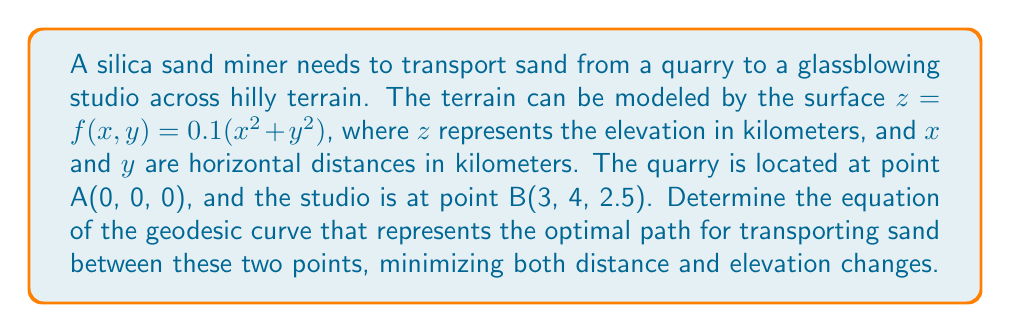Solve this math problem. To solve this problem, we'll use principles of differential geometry and the calculus of variations to find the geodesic curve on the given surface.

1. First, we need to parameterize the surface. Let's use the parameters $u$ and $v$:
   $x = u$, $y = v$, $z = 0.1(u^2 + v^2)$

2. The metric tensor for this surface is:
   $$g = \begin{bmatrix}
   1 + 0.04u^2 & 0.04uv \\
   0.04uv & 1 + 0.04v^2
   \end{bmatrix}$$

3. The geodesic equations are given by:
   $$\frac{d^2u}{ds^2} + \Gamma^u_{uu}\left(\frac{du}{ds}\right)^2 + 2\Gamma^u_{uv}\frac{du}{ds}\frac{dv}{ds} + \Gamma^u_{vv}\left(\frac{dv}{ds}\right)^2 = 0$$
   $$\frac{d^2v}{ds^2} + \Gamma^v_{uu}\left(\frac{du}{ds}\right)^2 + 2\Gamma^v_{uv}\frac{du}{ds}\frac{dv}{ds} + \Gamma^v_{vv}\left(\frac{dv}{ds}\right)^2 = 0$$

   where $\Gamma^i_{jk}$ are the Christoffel symbols.

4. Calculating the Christoffel symbols:
   $$\Gamma^u_{uu} = \frac{0.04u}{1 + 0.04u^2}, \Gamma^u_{uv} = \frac{-0.02v}{1 + 0.04u^2}, \Gamma^u_{vv} = \frac{0.04u}{1 + 0.04u^2}$$
   $$\Gamma^v_{uu} = \frac{0.04v}{1 + 0.04v^2}, \Gamma^v_{uv} = \frac{-0.02u}{1 + 0.04v^2}, \Gamma^v_{vv} = \frac{0.04v}{1 + 0.04v^2}$$

5. Substituting these into the geodesic equations gives us a system of differential equations. Due to the complexity of these equations, they typically need to be solved numerically.

6. The boundary conditions for our problem are:
   At $s = 0$: $u(0) = 0$, $v(0) = 0$
   At $s = 1$: $u(1) = 3$, $v(1) = 4$

7. Using a numerical method (such as the shooting method or finite differences) to solve this boundary value problem would give us the functions $u(s)$ and $v(s)$ that describe the geodesic curve.

8. The equation of the geodesic curve in the original $(x, y, z)$ coordinates would then be:
   $$x = u(s)$$
   $$y = v(s)$$
   $$z = 0.1(u(s)^2 + v(s)^2)$$
   for $0 \leq s \leq 1$
Answer: The equation of the geodesic curve representing the optimal path is:
$$x = u(s)$$
$$y = v(s)$$
$$z = 0.1(u(s)^2 + v(s)^2)$$
where $u(s)$ and $v(s)$ are the solutions to the geodesic equations with the given boundary conditions, and $0 \leq s \leq 1$. The exact functions $u(s)$ and $v(s)$ would need to be determined numerically due to the complexity of the equations. 